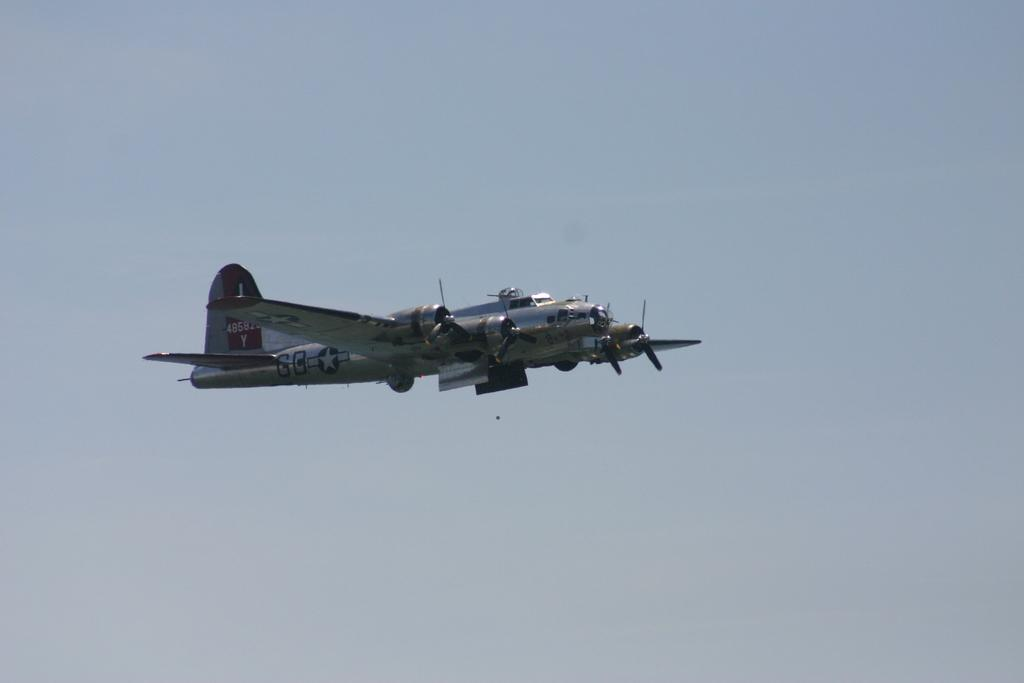<image>
Create a compact narrative representing the image presented. A metal plane with two letter Gs on the side flies through the air. 